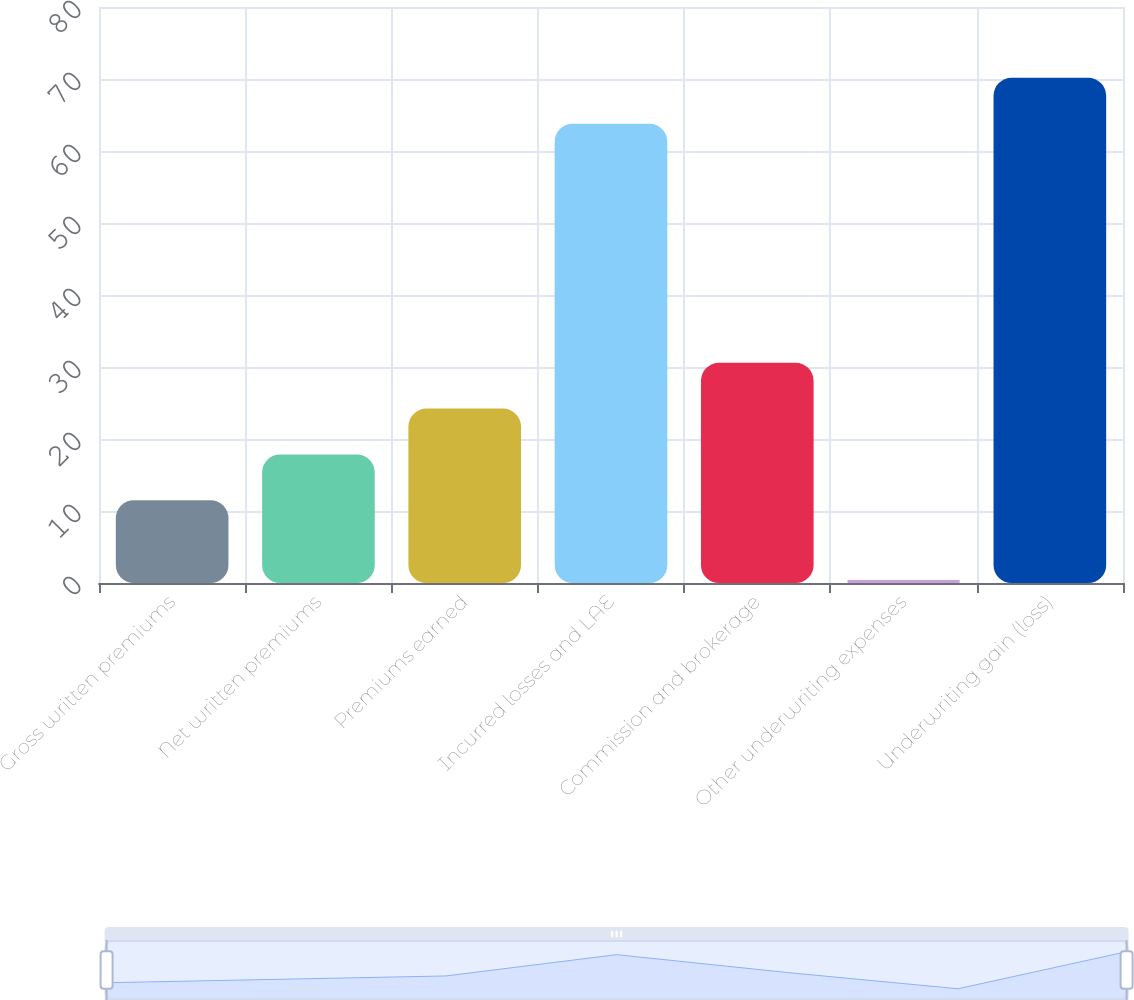Convert chart. <chart><loc_0><loc_0><loc_500><loc_500><bar_chart><fcel>Gross written premiums<fcel>Net written premiums<fcel>Premiums earned<fcel>Incurred losses and LAE<fcel>Commission and brokerage<fcel>Other underwriting expenses<fcel>Underwriting gain (loss)<nl><fcel>11.5<fcel>17.86<fcel>24.22<fcel>63.8<fcel>30.58<fcel>0.4<fcel>70.16<nl></chart> 